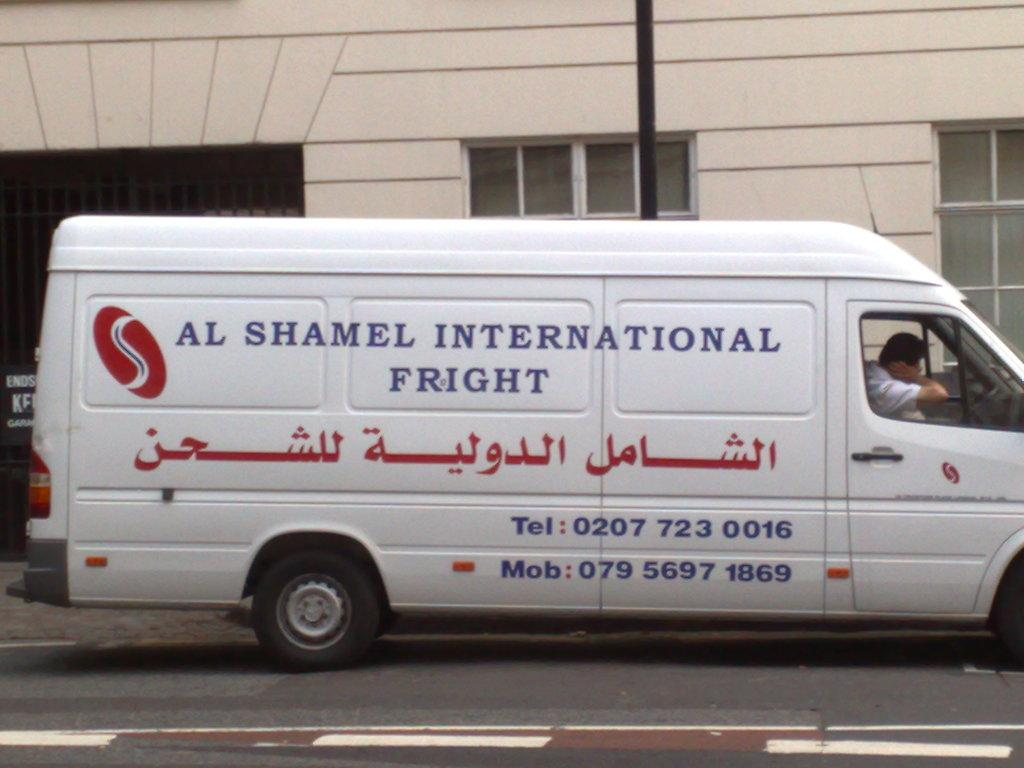<image>
Write a terse but informative summary of the picture. Al Shamel International Fright has a white panel van that lists their Tel as 0207 723 0016 and Mob as 079 5697 1869. 